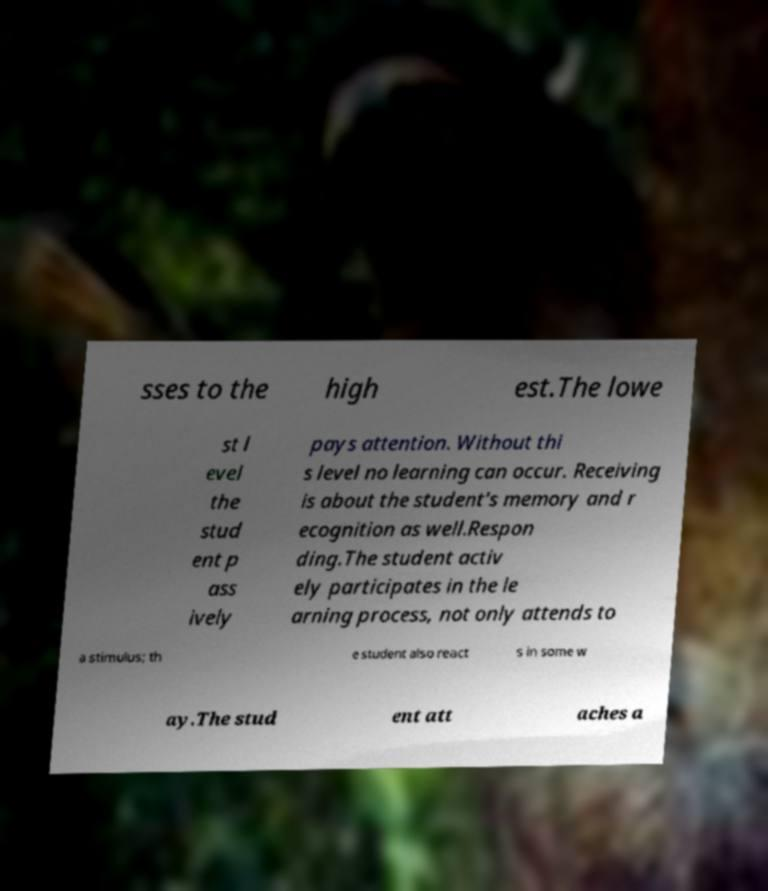Please identify and transcribe the text found in this image. sses to the high est.The lowe st l evel the stud ent p ass ively pays attention. Without thi s level no learning can occur. Receiving is about the student's memory and r ecognition as well.Respon ding.The student activ ely participates in the le arning process, not only attends to a stimulus; th e student also react s in some w ay.The stud ent att aches a 